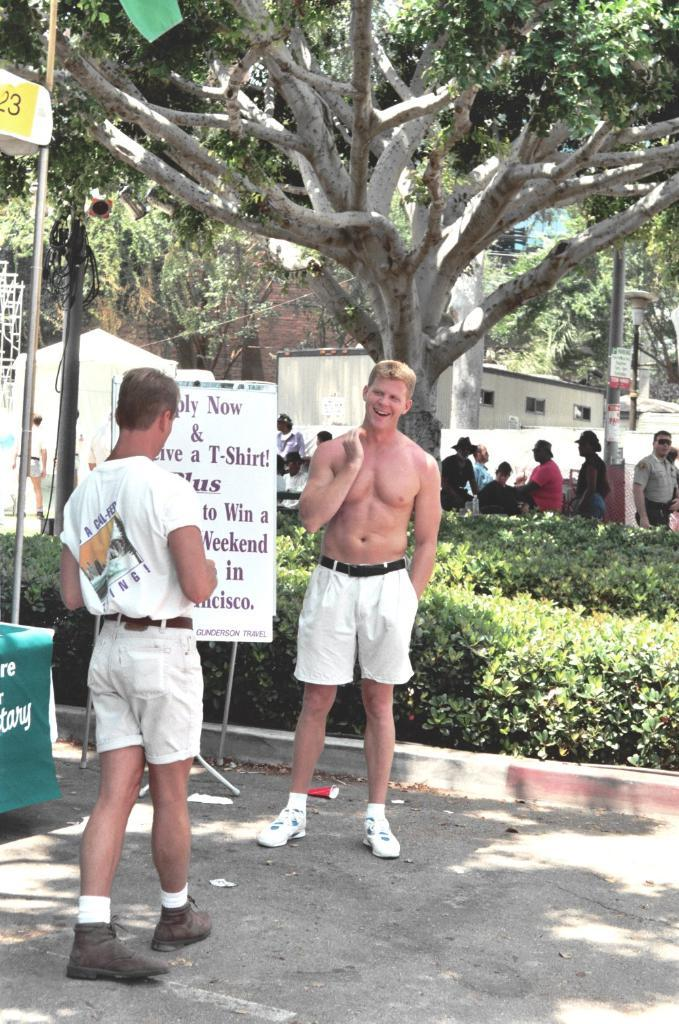<image>
Share a concise interpretation of the image provided. Two men laughing together near an apply now job sign. 